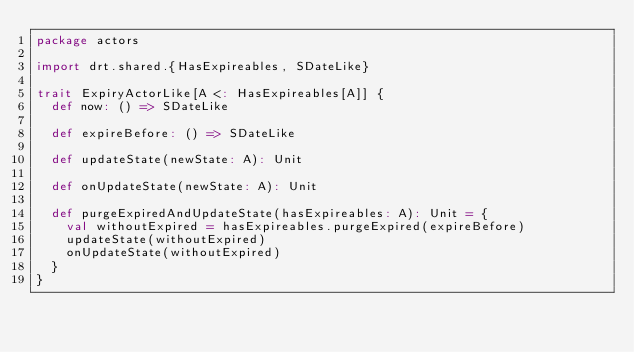<code> <loc_0><loc_0><loc_500><loc_500><_Scala_>package actors

import drt.shared.{HasExpireables, SDateLike}

trait ExpiryActorLike[A <: HasExpireables[A]] {
  def now: () => SDateLike

  def expireBefore: () => SDateLike

  def updateState(newState: A): Unit

  def onUpdateState(newState: A): Unit

  def purgeExpiredAndUpdateState(hasExpireables: A): Unit = {
    val withoutExpired = hasExpireables.purgeExpired(expireBefore)
    updateState(withoutExpired)
    onUpdateState(withoutExpired)
  }
}
</code> 